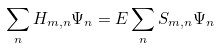<formula> <loc_0><loc_0><loc_500><loc_500>\sum _ { n } H _ { m , n } \Psi _ { n } = E \sum _ { n } S _ { m , n } \Psi _ { n }</formula> 